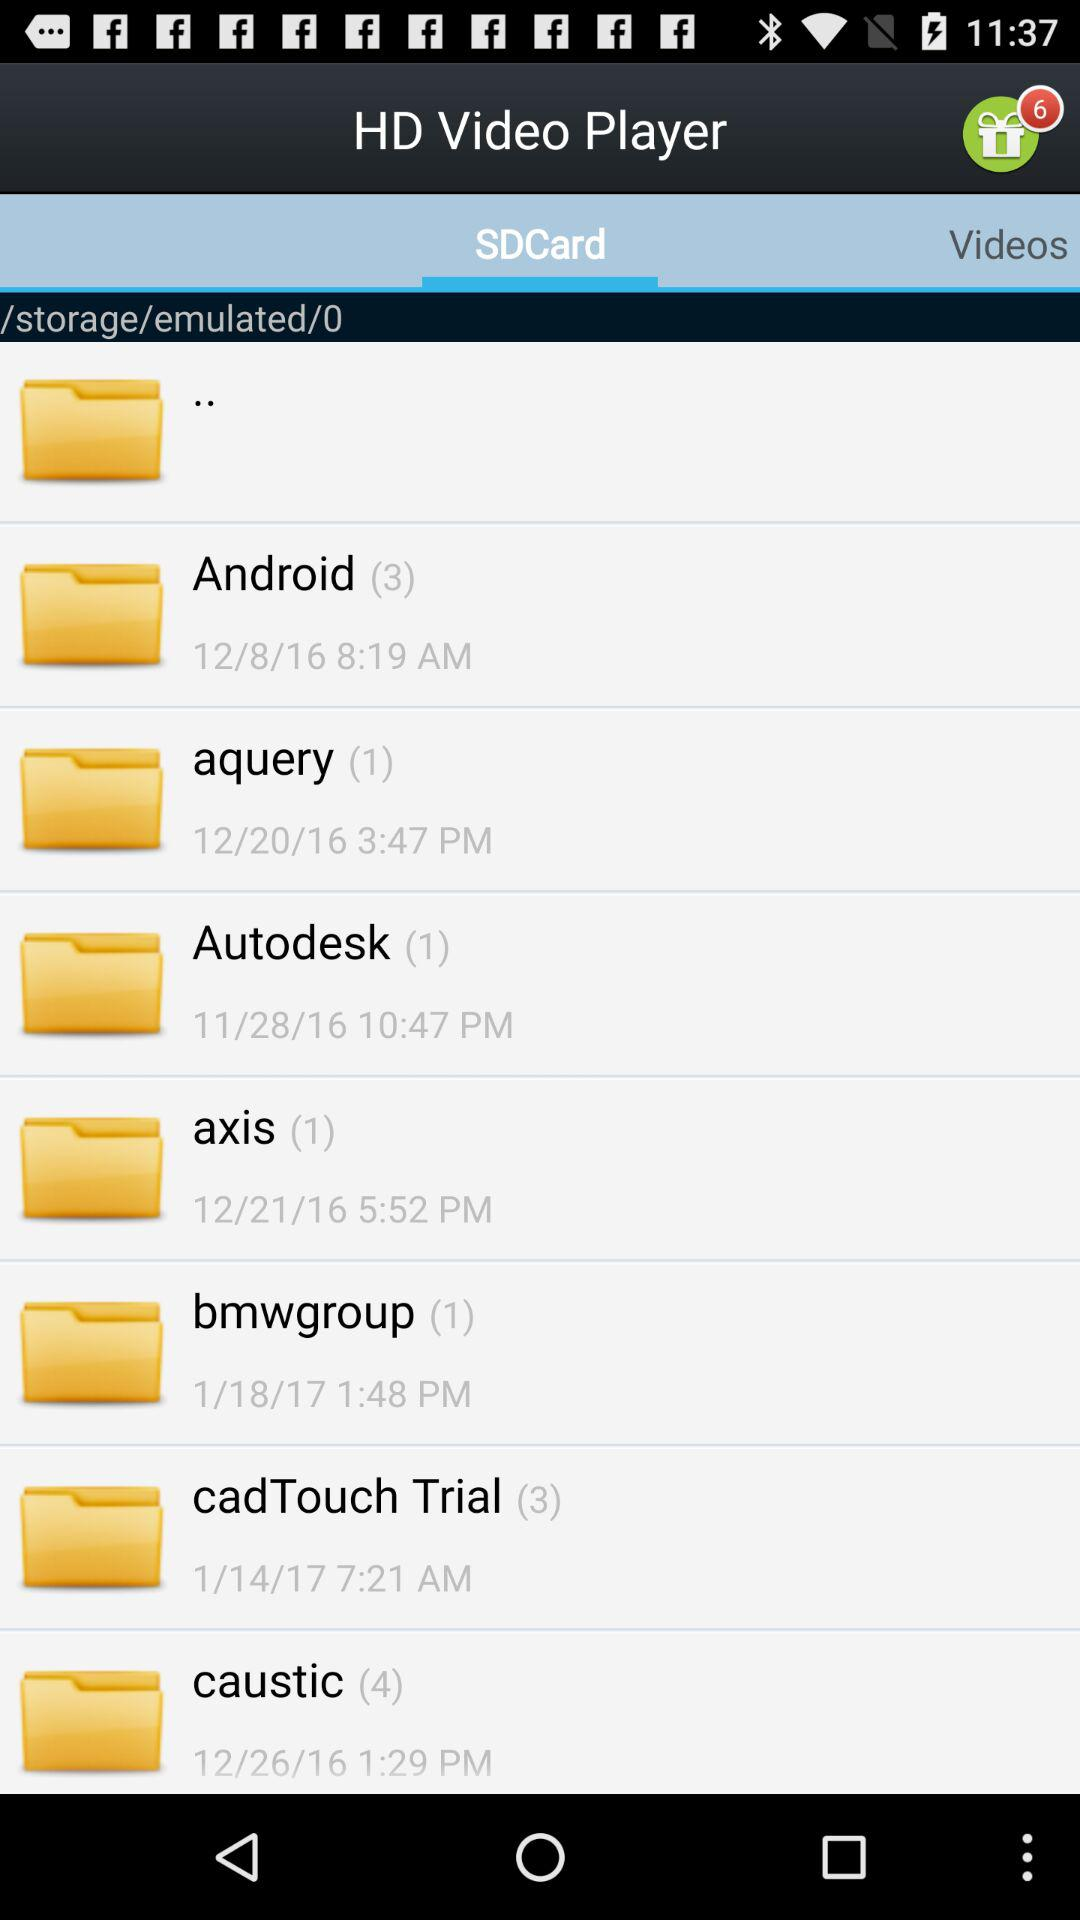What is the number of files in "Autodesk"? The number of files is 1. 